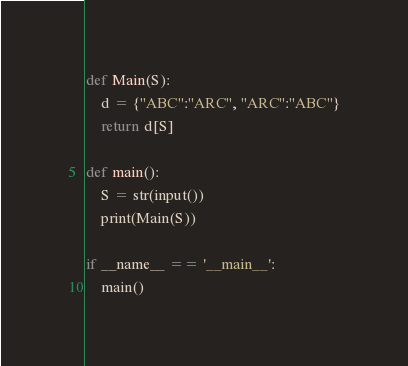<code> <loc_0><loc_0><loc_500><loc_500><_Python_>def Main(S):
    d = {"ABC":"ARC", "ARC":"ABC"}
    return d[S]

def main():
    S = str(input())
    print(Main(S))

if __name__ == '__main__':
    main()</code> 